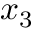Convert formula to latex. <formula><loc_0><loc_0><loc_500><loc_500>x _ { 3 }</formula> 